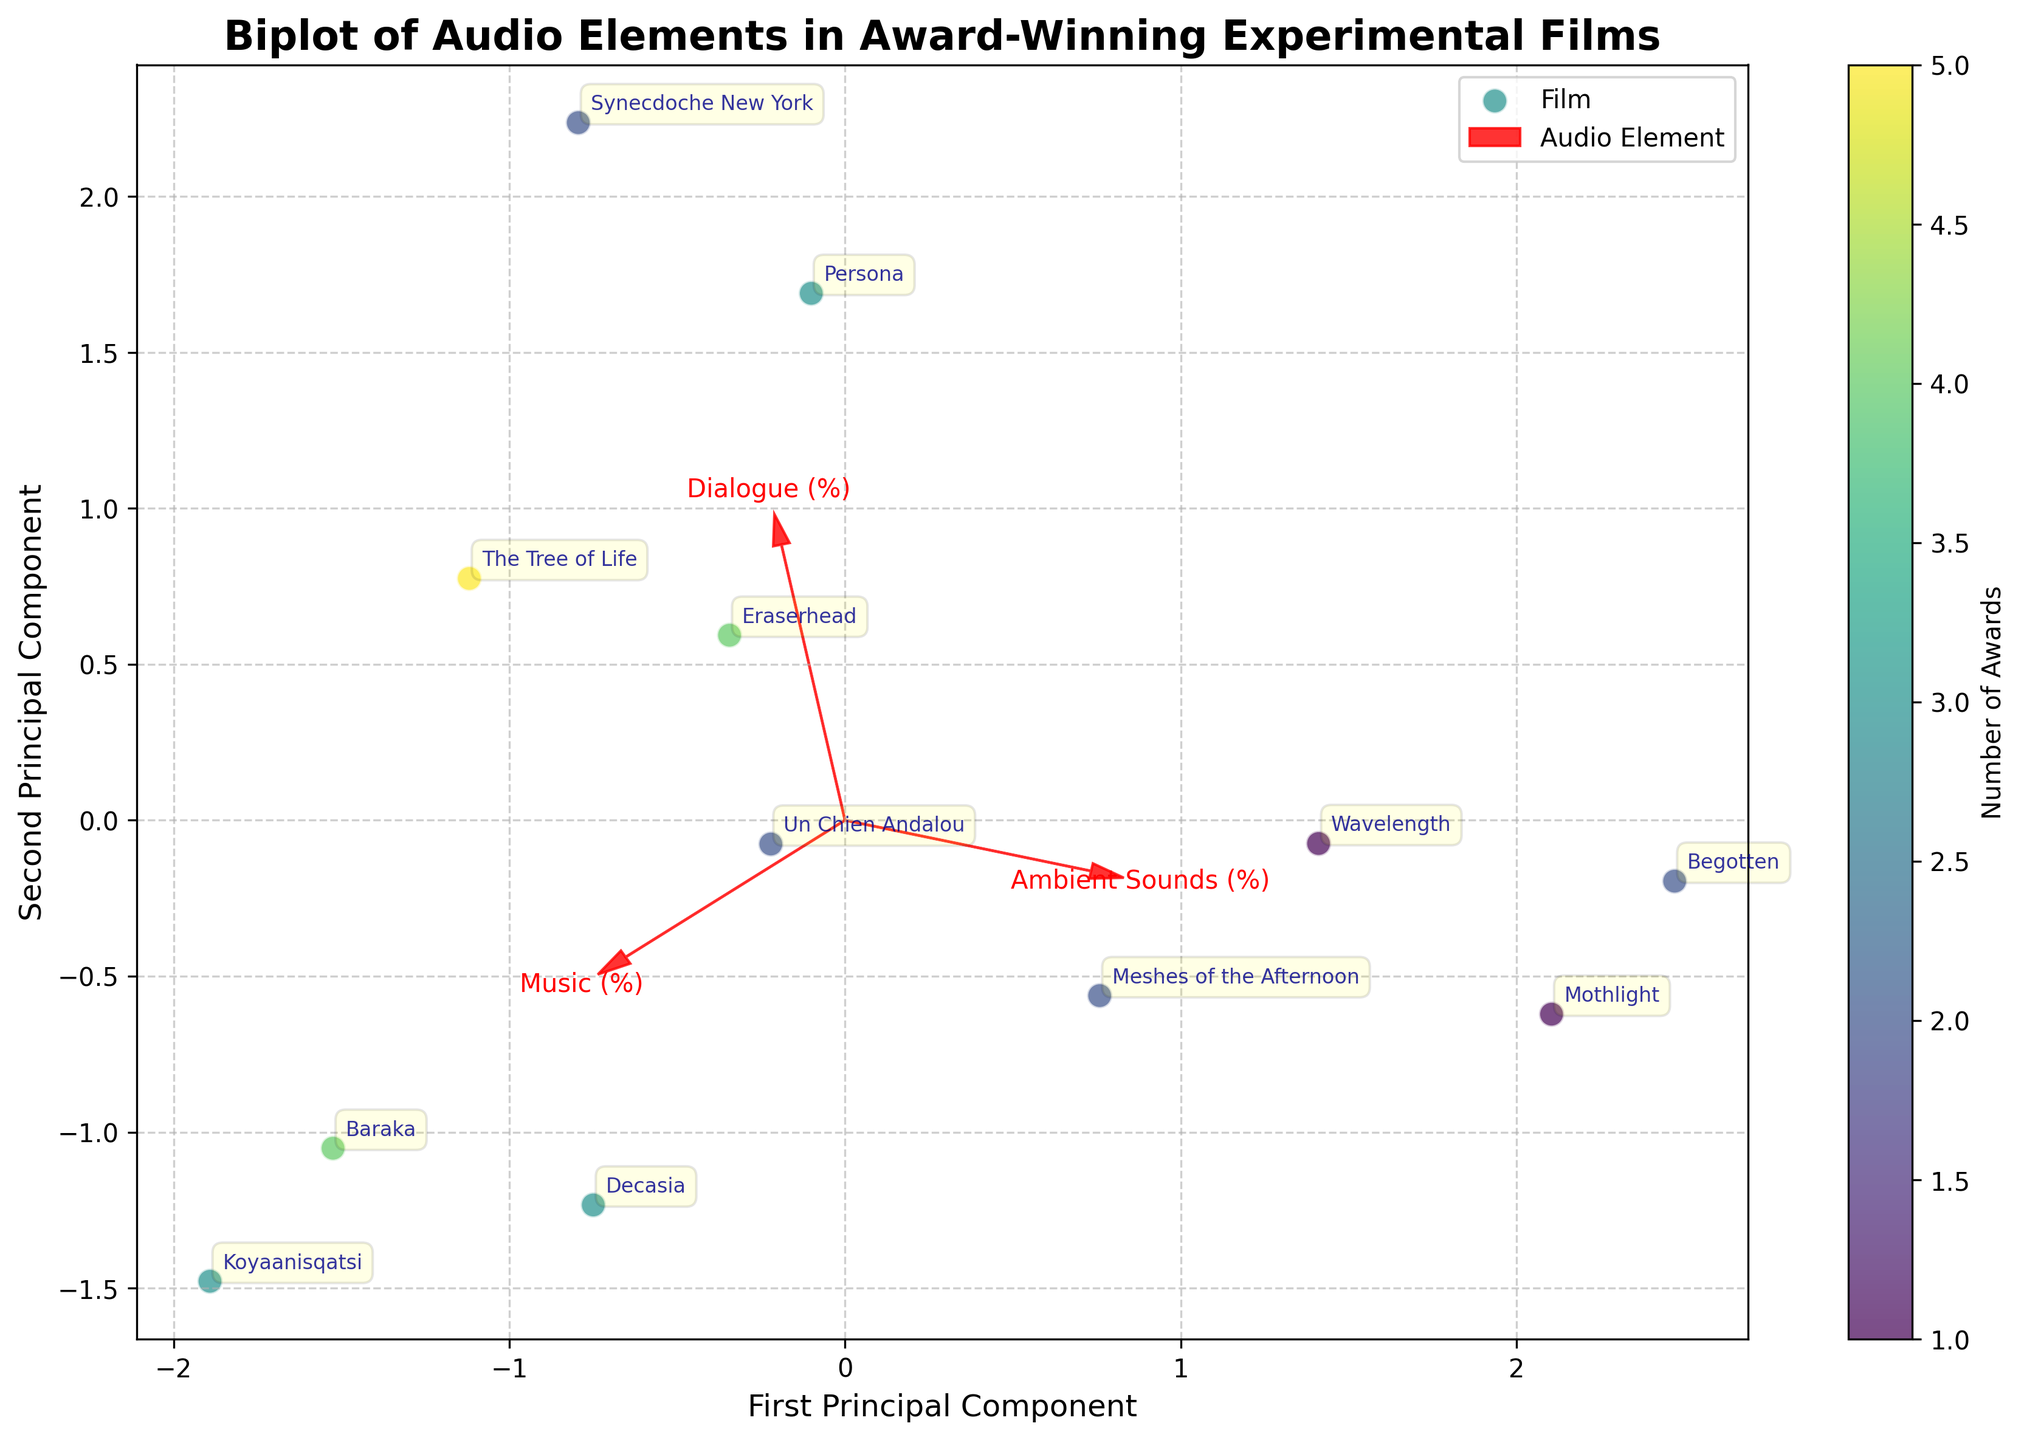What is the title of the figure? The title is prominently displayed at the top of the figure, indicating the focus of the visualization.
Answer: Biplot of Audio Elements in Award-Winning Experimental Films What do the arrows in the figure represent? The arrows represent the feature vectors of the audio elements: Dialogue, Music, and Ambient Sounds. They show the direction and magnitude of each feature's contribution to the principal components.
Answer: Feature vectors of audio elements Which film has the highest score on the first principal component? The annotation next to the data point furthest to the right on the x-axis indicates the film with the highest score on the first principal component.
Answer: Synecdoche New York Which audio element has the highest loading on the second principal component? The arrow that extends furthest along the y-axis represents the audio element with the highest loading on the second principal component.
Answer: Ambient Sounds How many films are included in the biplot? Count the number of annotated film titles within the plot area.
Answer: 12 What color represents films with the highest number of awards? The colorbar indicates that darker shades of green represent films with higher awards. By looking at the scatter points and referencing the colorbar, the specific color can be identified.
Answer: Dark green Which film relies mostly on ambient sounds rather than dialogue or music? By observing the distribution of points and noting the one closest to the Ambient Sounds arrow and farthest from the Dialogue and Music arrows, the relevant film can be determined.
Answer: Begotten How are the films "Koyaanisqatsi" and "Baraka" different in terms of their audio elements? Compare the relative positions and the direction of the arrows for these two films. "Koyaanisqatsi" is closer to the Music arrow, while "Baraka" is also nearer to the Music arrow but in a different position indicating they both have high percentages of music but differ slightly in other elements.
Answer: Both have high Music content, but differ slightly in other elements Which audio element contributes more to the first principal component? The length and direction of the arrows for Dialogue, Music, and Ambient Sounds with respect to the x-axis will indicate their contributions to the first principal component. The longer the arrow along the x-axis, the greater its contribution.
Answer: Music Is there any film that does not contain any dialogue? By identifying the data points labeled with film titles and checking the corresponding position close to the Dialogue axis, films with a zero percentage of dialogue can be pinpointed.
Answer: Koyaanisqatsi, Mothlight, Decasia 